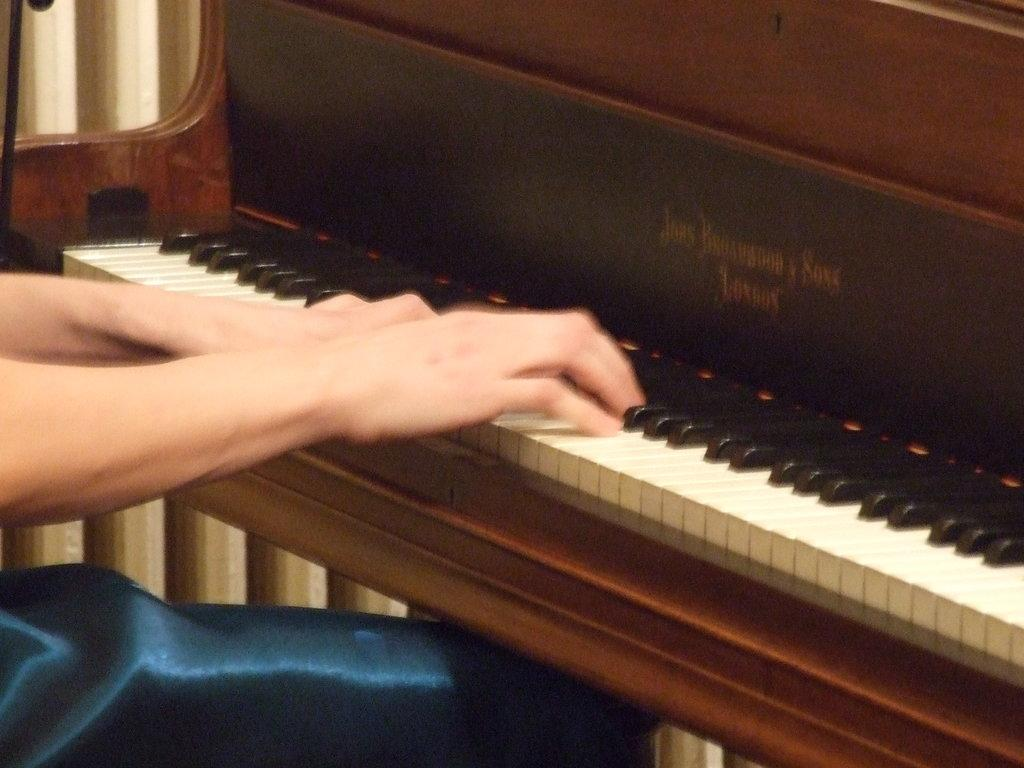What is the main object in the image? There is a piano in the image. Can you describe the person in the image? There is a person in front of the piano. Where is the library located in the image? There is no library present in the image. Is the person in the image kissing their mother? There is no indication of a mother or a kiss in the image. 